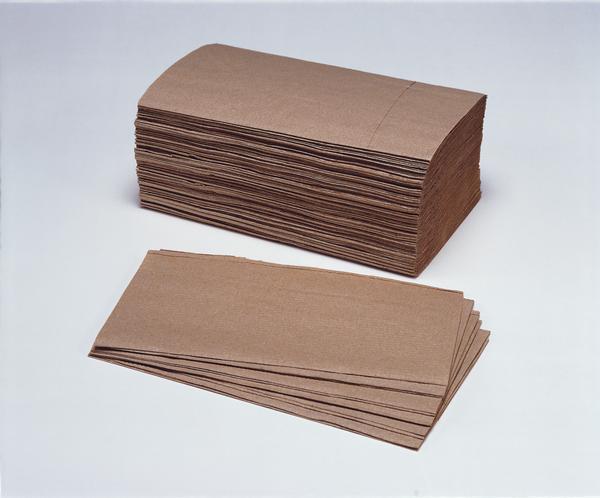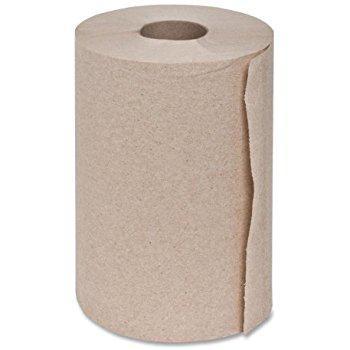The first image is the image on the left, the second image is the image on the right. Evaluate the accuracy of this statement regarding the images: "There is a folded paper towel on one of the images.". Is it true? Answer yes or no. Yes. 